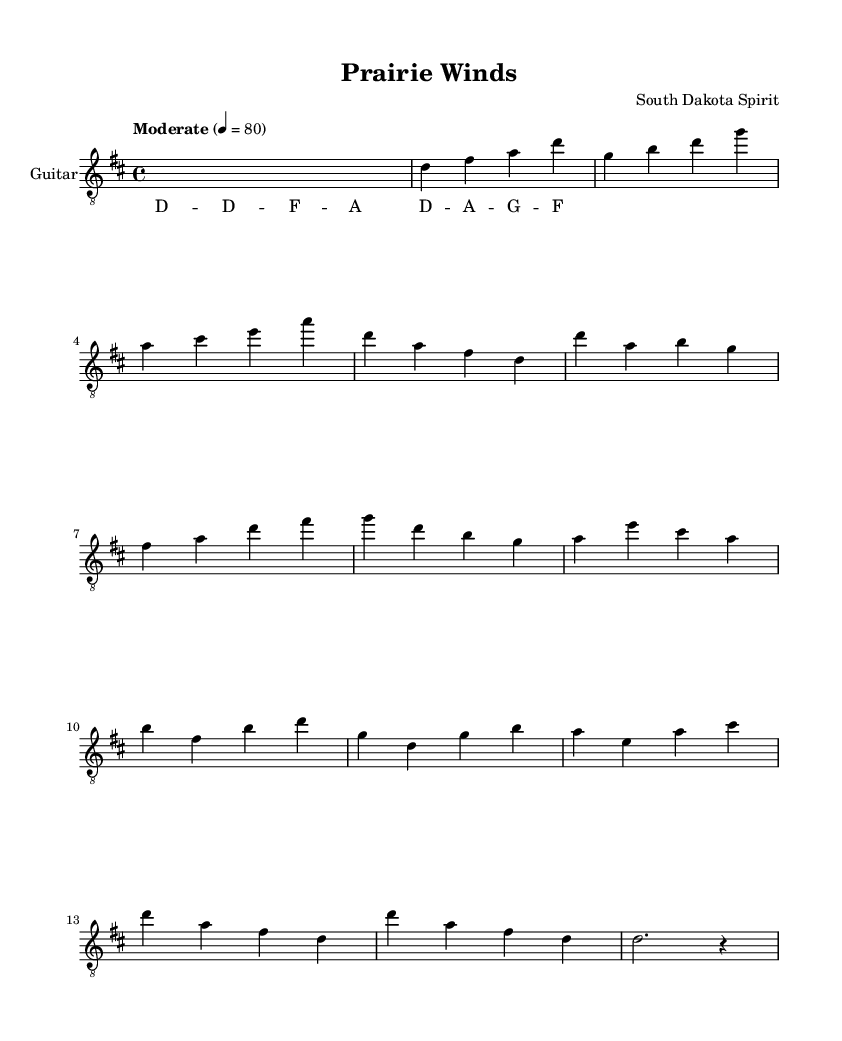What is the key signature of this music? The key signature is D major, which has two sharps (F# and C#). This can be identified by looking at the key signature shown at the beginning of the music.
Answer: D major What is the time signature of this piece? The time signature is 4/4, which indicates that there are four beats in each measure and the quarter note receives one beat. This is explicitly noted at the beginning of the music.
Answer: 4/4 What is the tempo marking? The tempo marking for this piece is "Moderate" at a speed of 80 beats per minute. This can be found in the tempo indication at the start of the music.
Answer: Moderate 80 How many measures are there in the song? The song consists of 21 measures, which can be counted by analyzing the structure of the music, including the intro, verses, chorus, bridge, and outro, while marking the start and end of each measure.
Answer: 21 What is the overall form of this piece? The overall form of the piece is Intro - Verse - Chorus - Bridge - Outro. This can be determined by observing the sections labeled in the music and understanding the structure typical of instrumental compositions evoking themes such as landscapes.
Answer: Intro - Verse - Chorus - Bridge - Outro What is the highest note played in this sheet music? The highest note in the music is A, which is reached in several sections, notably in the chorus and the outro. By scanning the music from top to bottom, the A notes clearly stand out being the highest in pitch.
Answer: A What style of guitar play is suggested in the instructions? The suggested style in the fingering instructions hints at a fingerstyle approach, as indicated by specifying fingering orientations and the structure of the notes. This reflects the method often used for evoking rich acoustic textures that resonate with the landscapes of South Dakota.
Answer: Fingerstyle 